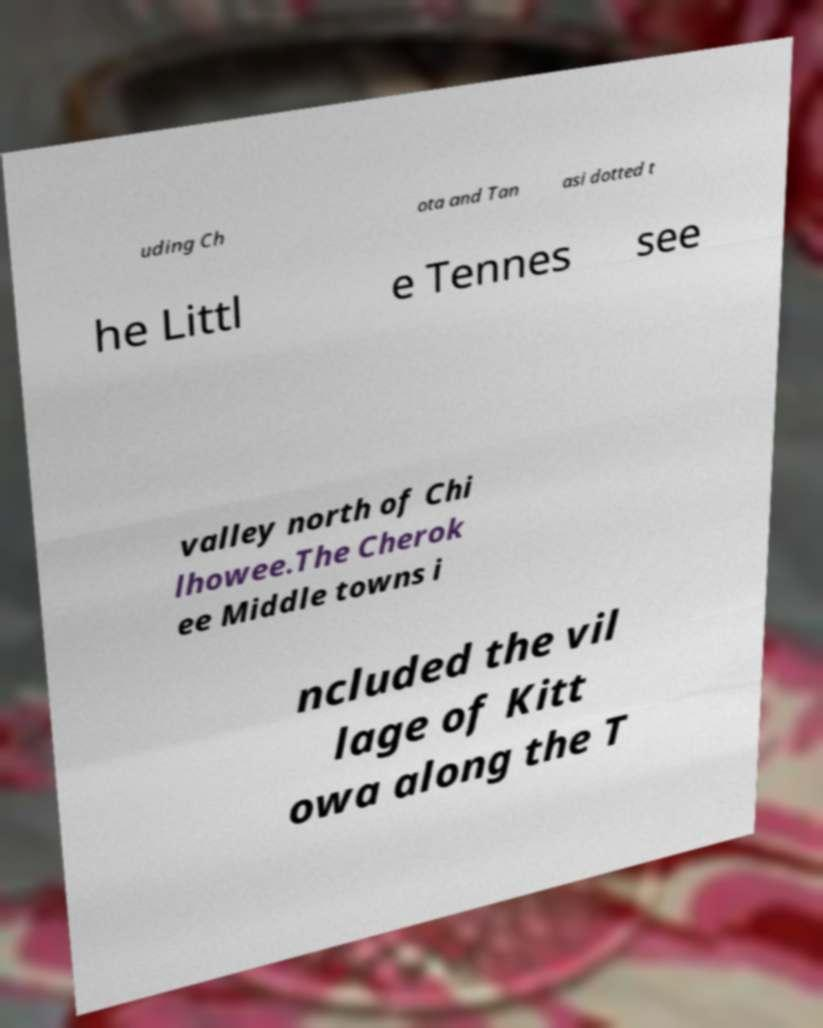Could you assist in decoding the text presented in this image and type it out clearly? uding Ch ota and Tan asi dotted t he Littl e Tennes see valley north of Chi lhowee.The Cherok ee Middle towns i ncluded the vil lage of Kitt owa along the T 